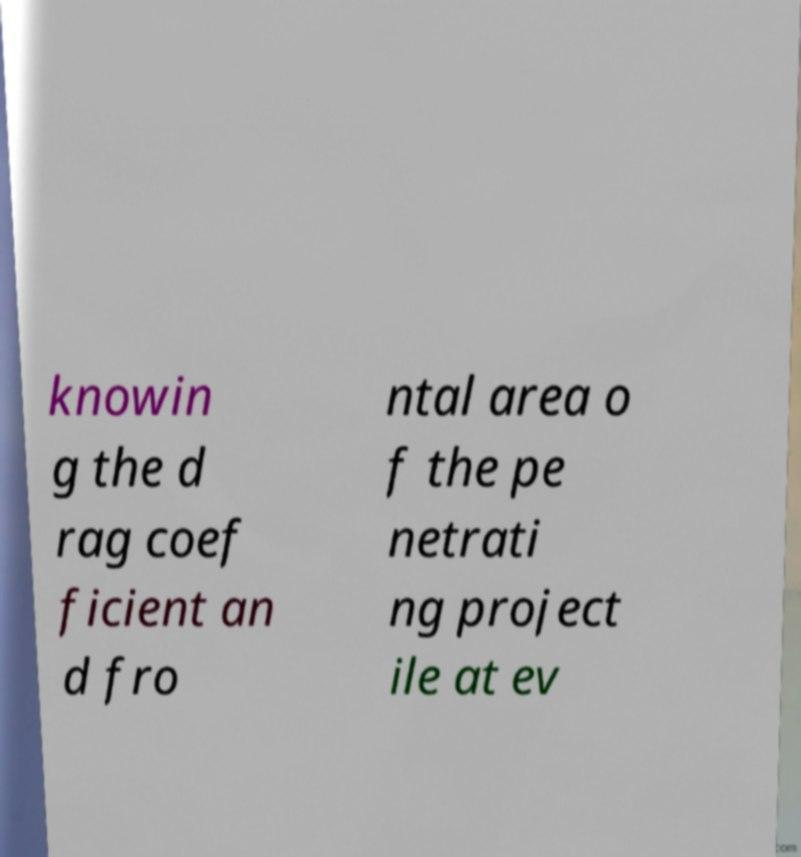What messages or text are displayed in this image? I need them in a readable, typed format. knowin g the d rag coef ficient an d fro ntal area o f the pe netrati ng project ile at ev 